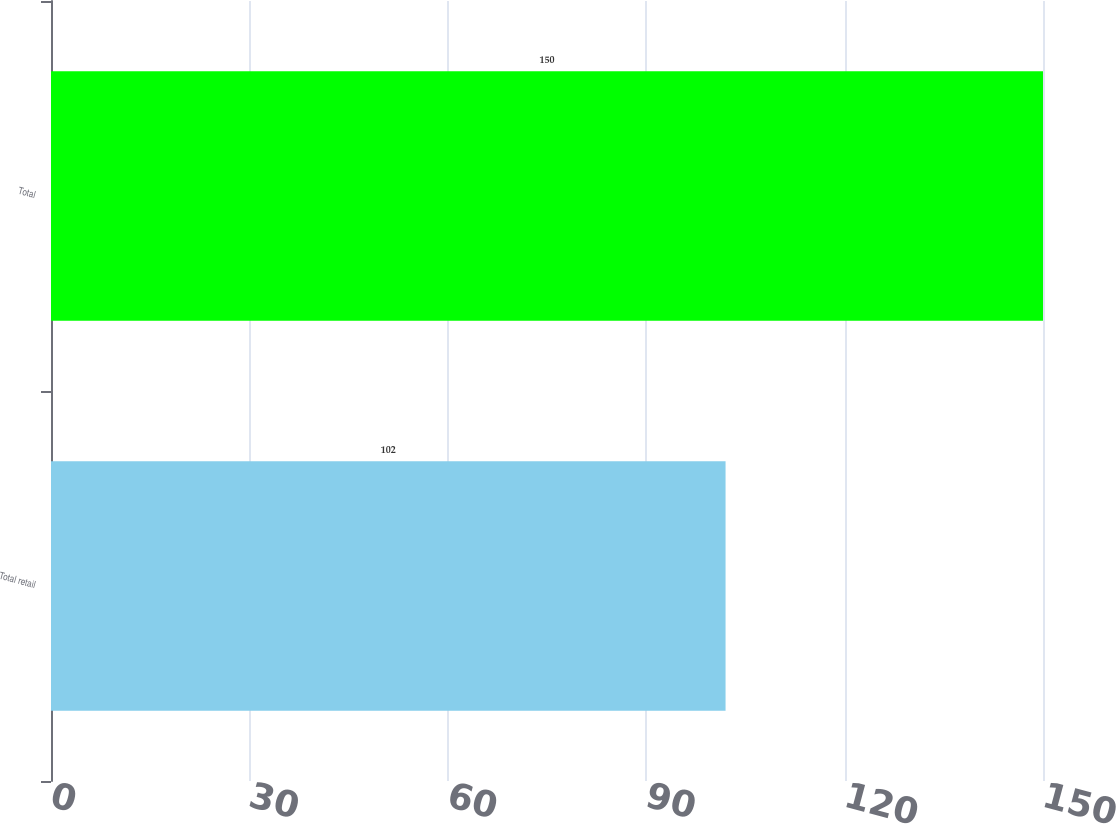<chart> <loc_0><loc_0><loc_500><loc_500><bar_chart><fcel>Total retail<fcel>Total<nl><fcel>102<fcel>150<nl></chart> 